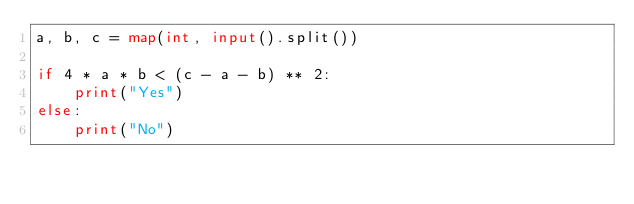Convert code to text. <code><loc_0><loc_0><loc_500><loc_500><_Python_>a, b, c = map(int, input().split())

if 4 * a * b < (c - a - b) ** 2:
    print("Yes")
else:
    print("No")
</code> 